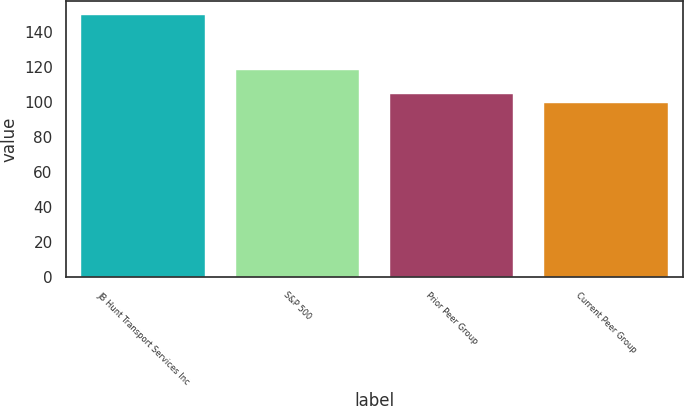<chart> <loc_0><loc_0><loc_500><loc_500><bar_chart><fcel>JB Hunt Transport Services Inc<fcel>S&P 500<fcel>Prior Peer Group<fcel>Current Peer Group<nl><fcel>149.94<fcel>118.45<fcel>104.48<fcel>99.43<nl></chart> 